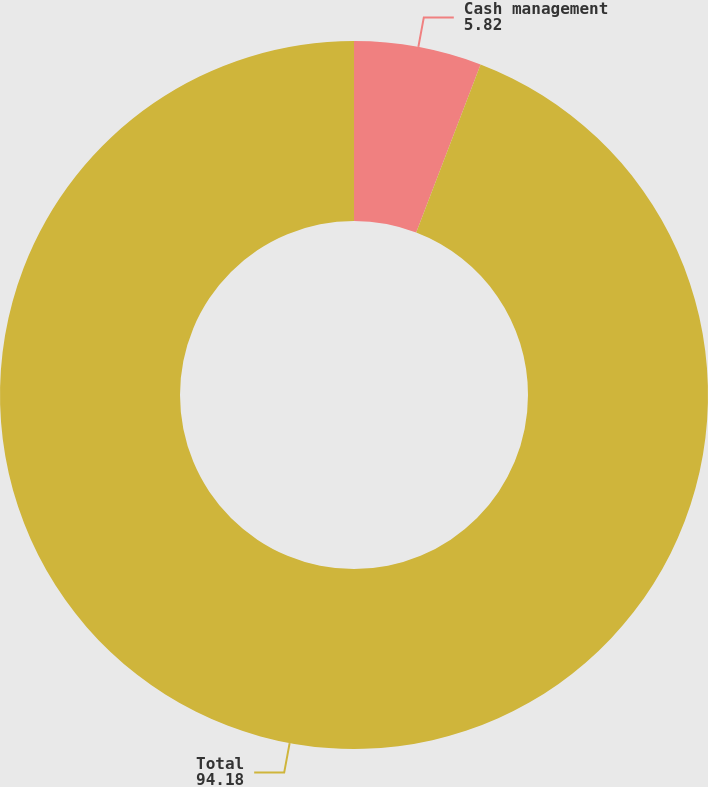Convert chart to OTSL. <chart><loc_0><loc_0><loc_500><loc_500><pie_chart><fcel>Cash management<fcel>Total<nl><fcel>5.82%<fcel>94.18%<nl></chart> 